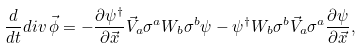Convert formula to latex. <formula><loc_0><loc_0><loc_500><loc_500>\frac { d } { d t } d i v \, \vec { \phi } = - \frac { \partial \psi ^ { \dagger } } { \partial \vec { x } } \vec { V } _ { a } \sigma ^ { a } W _ { b } \sigma ^ { b } \psi - \psi ^ { \dagger } W _ { b } \sigma ^ { b } \vec { V } _ { a } \sigma ^ { a } \frac { \partial \psi } { \partial \vec { x } } ,</formula> 